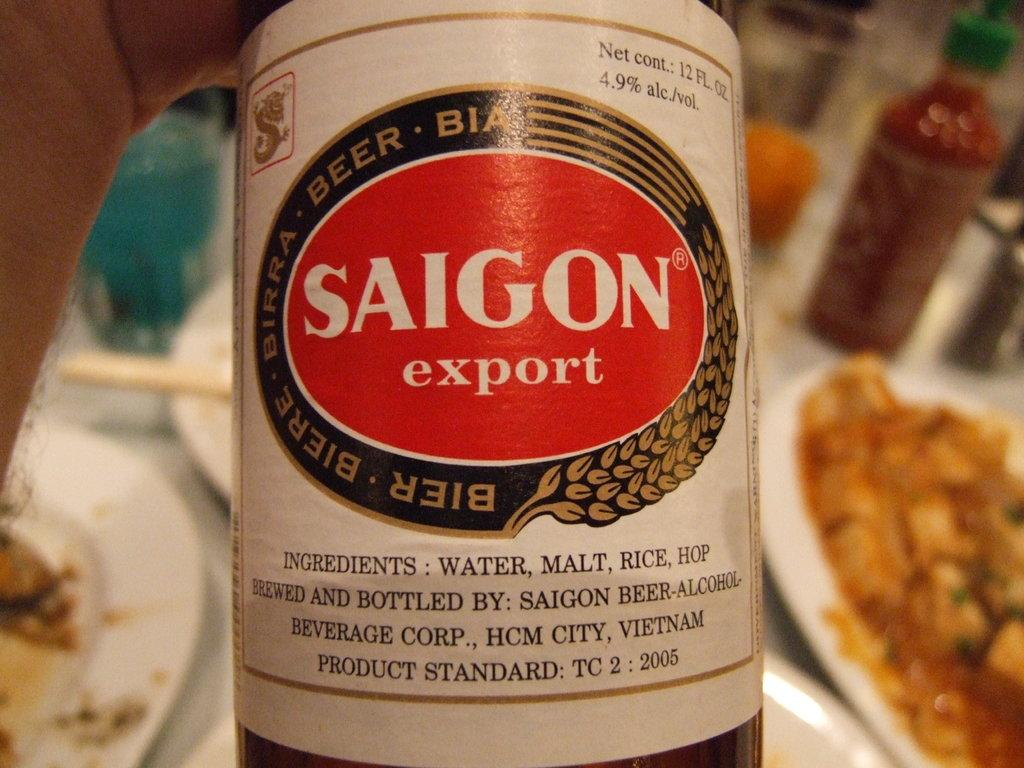<image>
Summarize the visual content of the image. Someone is holding a Saigon export beer in their hand. 